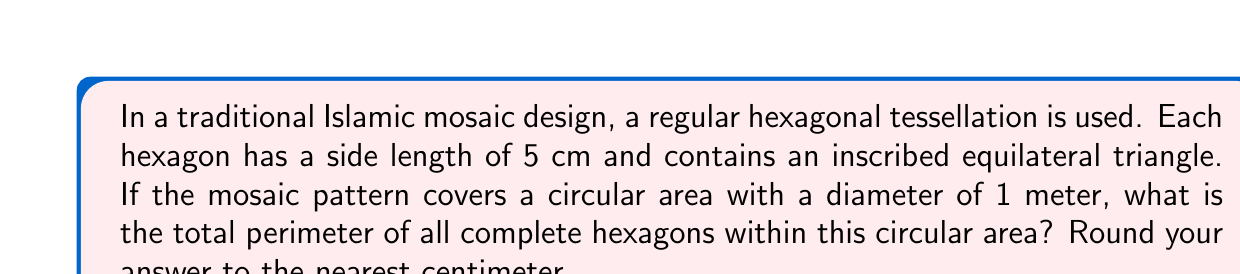Help me with this question. Let's approach this step-by-step:

1) First, we need to calculate the area of one hexagon:
   Area of a regular hexagon = $\frac{3\sqrt{3}}{2}a^2$, where $a$ is the side length
   Area = $\frac{3\sqrt{3}}{2}(5^2) = 64.95$ cm²

2) Now, let's calculate the area of the circular mosaic:
   Area of circle = $\pi r^2 = \pi (50^2) = 7853.98$ cm²

3) To find the number of complete hexagons, divide the circle area by the hexagon area:
   Number of hexagons = $7853.98 / 64.95 \approx 120.92$
   Rounding down, we have 120 complete hexagons

4) The perimeter of one hexagon is:
   Perimeter = $6 * 5 = 30$ cm

5) Total perimeter of all hexagons:
   Total perimeter = $120 * 30 = 3600$ cm

Therefore, the total perimeter of all complete hexagons is 3600 cm.

[asy]
unitsize(1cm);
real r = 5;
pair[] hexagon;
for (int i=0; i<6; ++i) {
  hexagon.push(r*dir(60*i));
}
for (int i=0; i<6; ++i) {
  draw(hexagon[i]--hexagon[(i+1)%6]);
}
draw(circle((0,0),10), dashed);
label("1m diameter", (0,-11));
[/asy]
Answer: 3600 cm 